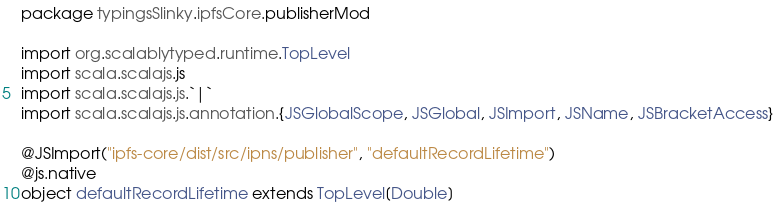<code> <loc_0><loc_0><loc_500><loc_500><_Scala_>package typingsSlinky.ipfsCore.publisherMod

import org.scalablytyped.runtime.TopLevel
import scala.scalajs.js
import scala.scalajs.js.`|`
import scala.scalajs.js.annotation.{JSGlobalScope, JSGlobal, JSImport, JSName, JSBracketAccess}

@JSImport("ipfs-core/dist/src/ipns/publisher", "defaultRecordLifetime")
@js.native
object defaultRecordLifetime extends TopLevel[Double]
</code> 